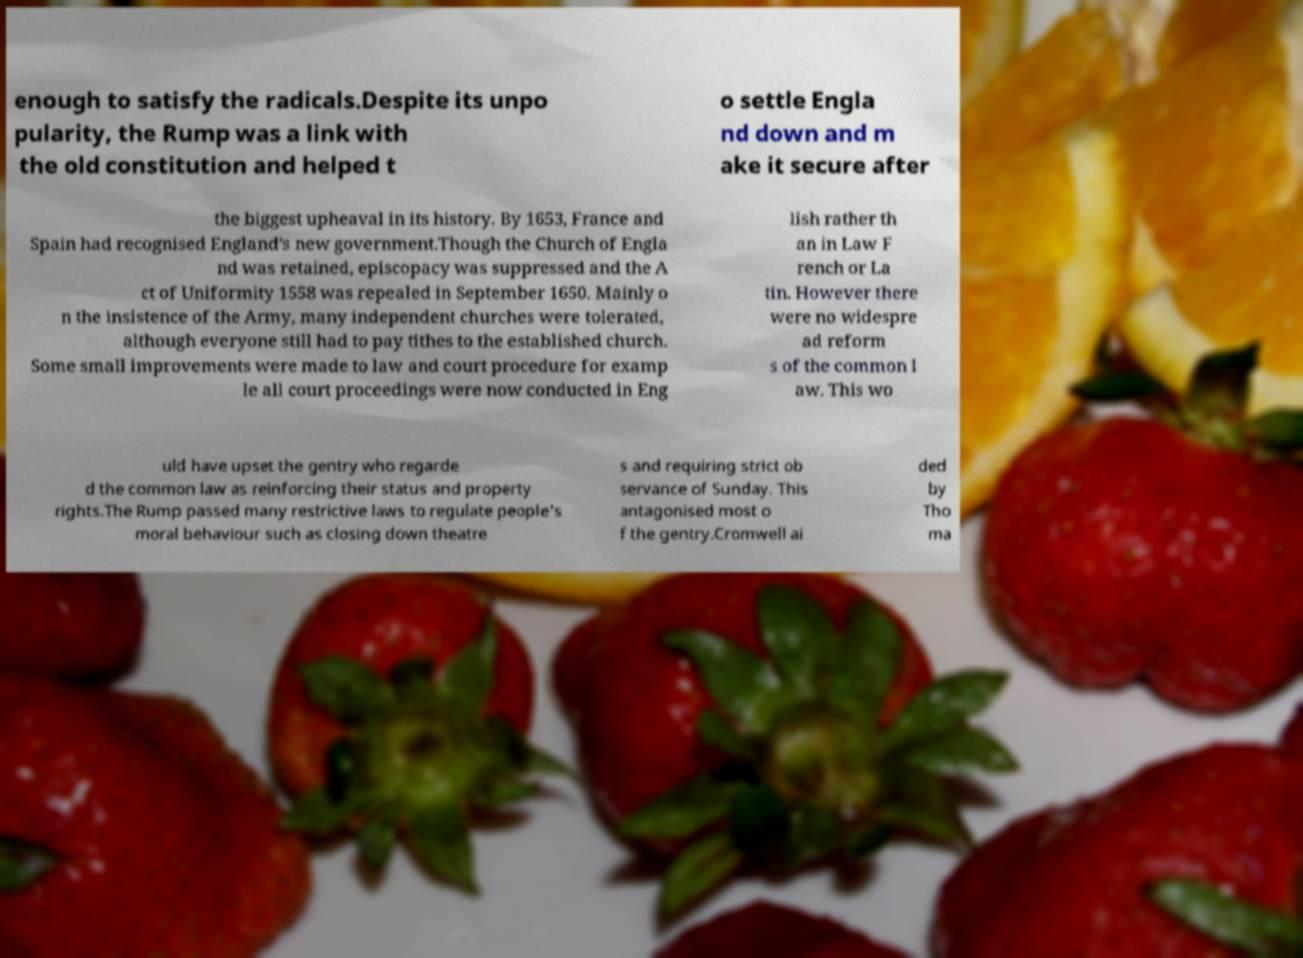What messages or text are displayed in this image? I need them in a readable, typed format. enough to satisfy the radicals.Despite its unpo pularity, the Rump was a link with the old constitution and helped t o settle Engla nd down and m ake it secure after the biggest upheaval in its history. By 1653, France and Spain had recognised England's new government.Though the Church of Engla nd was retained, episcopacy was suppressed and the A ct of Uniformity 1558 was repealed in September 1650. Mainly o n the insistence of the Army, many independent churches were tolerated, although everyone still had to pay tithes to the established church. Some small improvements were made to law and court procedure for examp le all court proceedings were now conducted in Eng lish rather th an in Law F rench or La tin. However there were no widespre ad reform s of the common l aw. This wo uld have upset the gentry who regarde d the common law as reinforcing their status and property rights.The Rump passed many restrictive laws to regulate people's moral behaviour such as closing down theatre s and requiring strict ob servance of Sunday. This antagonised most o f the gentry.Cromwell ai ded by Tho ma 